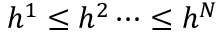Convert formula to latex. <formula><loc_0><loc_0><loc_500><loc_500>h ^ { 1 } \leq h ^ { 2 } \dots \leq h ^ { N }</formula> 